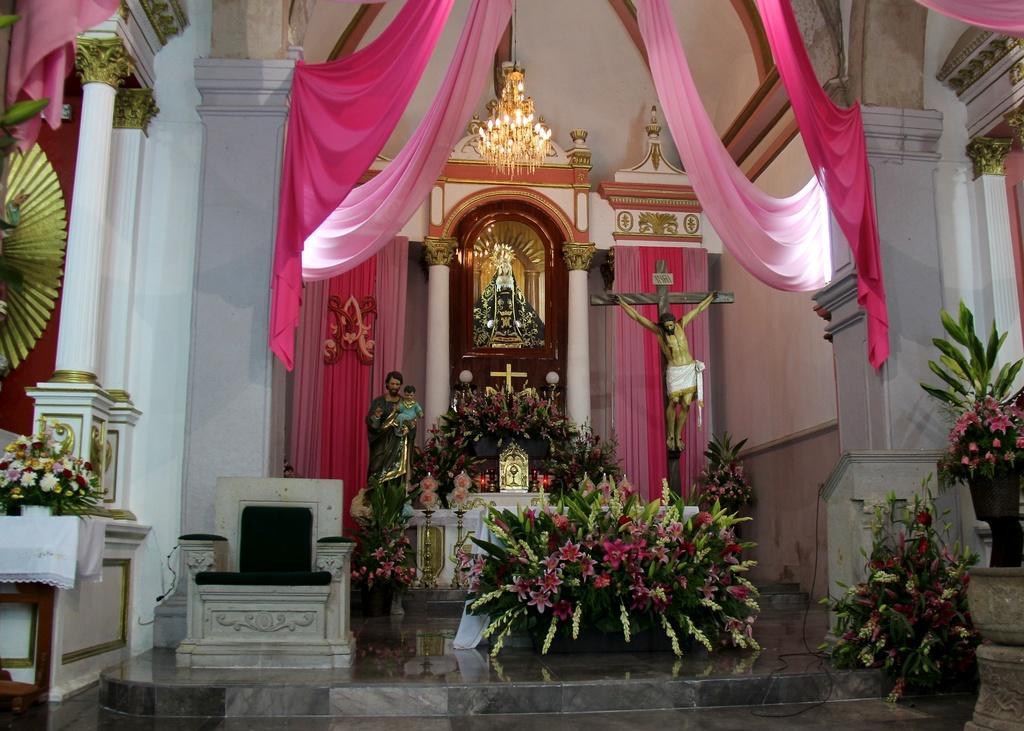Could you give a brief overview of what you see in this image? This is the inside view of a church. Here we can see sculptures, plants, flowers, curtains, lights, chair, and wall. 